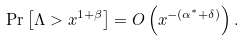Convert formula to latex. <formula><loc_0><loc_0><loc_500><loc_500>\Pr \left [ \Lambda > x ^ { 1 + \beta } \right ] = O \left ( x ^ { - ( \alpha ^ { \ast } + \delta ) } \right ) .</formula> 